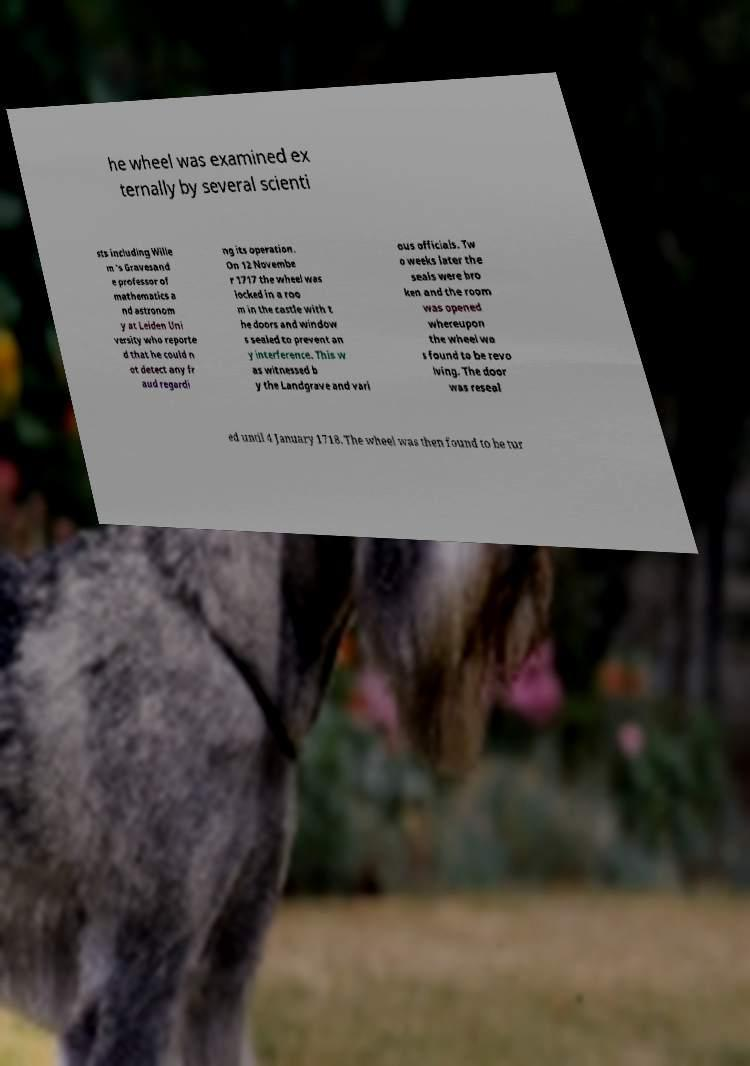I need the written content from this picture converted into text. Can you do that? he wheel was examined ex ternally by several scienti sts including Wille m 's Gravesand e professor of mathematics a nd astronom y at Leiden Uni versity who reporte d that he could n ot detect any fr aud regardi ng its operation. On 12 Novembe r 1717 the wheel was locked in a roo m in the castle with t he doors and window s sealed to prevent an y interference. This w as witnessed b y the Landgrave and vari ous officials. Tw o weeks later the seals were bro ken and the room was opened whereupon the wheel wa s found to be revo lving. The door was reseal ed until 4 January 1718. The wheel was then found to be tur 